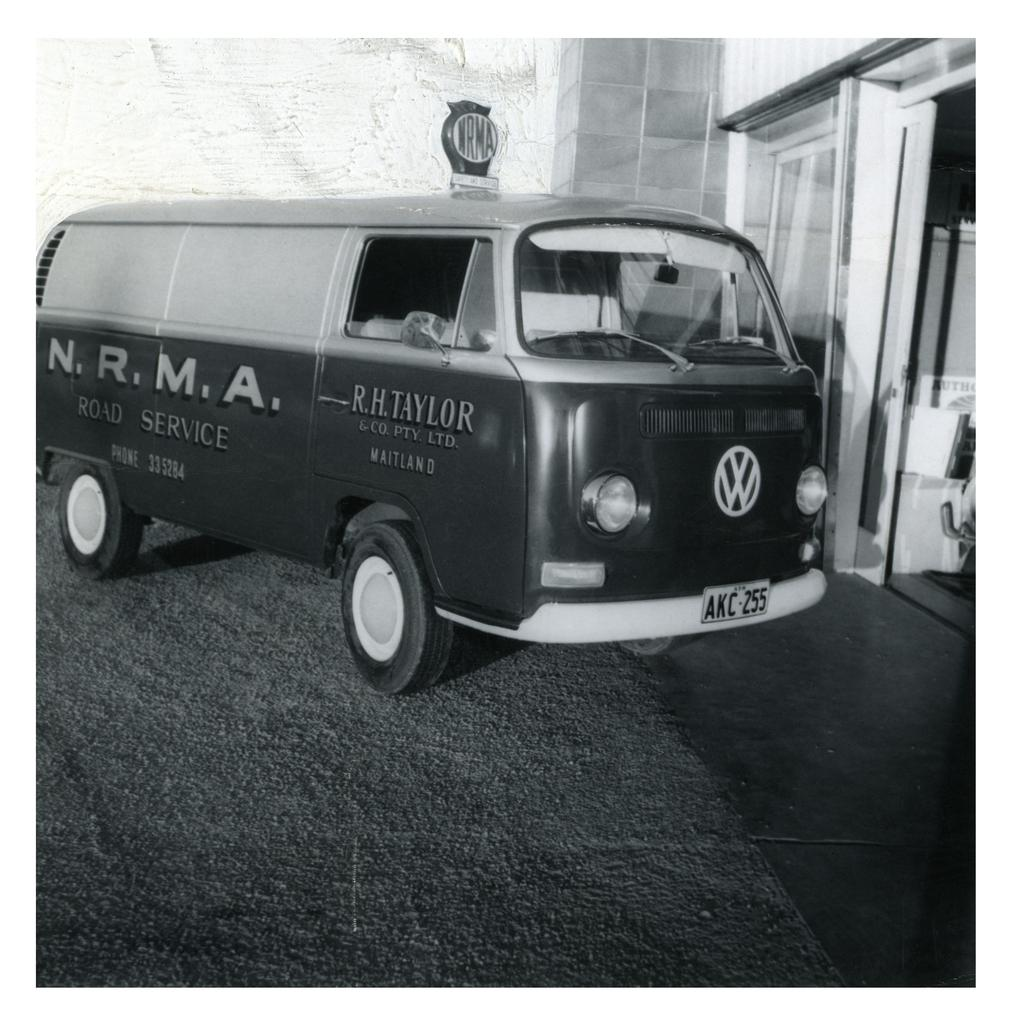<image>
Summarize the visual content of the image. A VW van has NRMA on the passenger side of the van. 